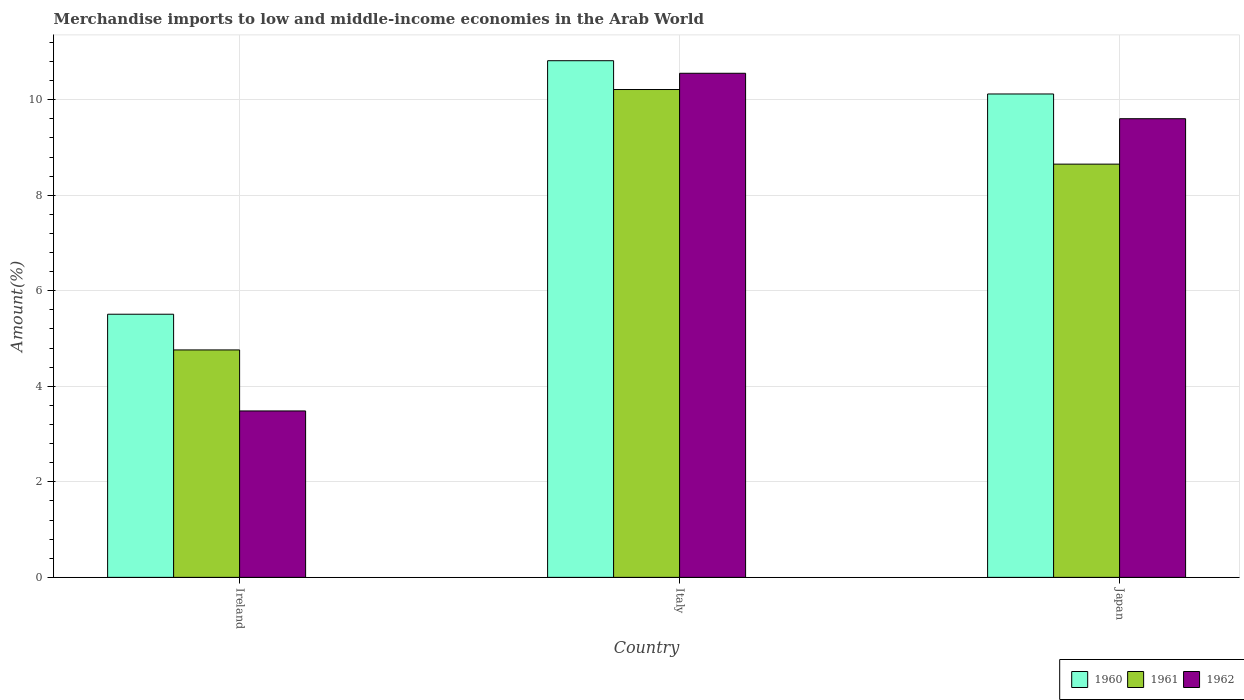How many different coloured bars are there?
Give a very brief answer. 3. How many groups of bars are there?
Your response must be concise. 3. How many bars are there on the 2nd tick from the right?
Offer a terse response. 3. What is the percentage of amount earned from merchandise imports in 1962 in Japan?
Provide a short and direct response. 9.6. Across all countries, what is the maximum percentage of amount earned from merchandise imports in 1962?
Offer a very short reply. 10.55. Across all countries, what is the minimum percentage of amount earned from merchandise imports in 1960?
Keep it short and to the point. 5.51. In which country was the percentage of amount earned from merchandise imports in 1961 maximum?
Provide a short and direct response. Italy. In which country was the percentage of amount earned from merchandise imports in 1960 minimum?
Your answer should be compact. Ireland. What is the total percentage of amount earned from merchandise imports in 1961 in the graph?
Provide a succinct answer. 23.63. What is the difference between the percentage of amount earned from merchandise imports in 1961 in Italy and that in Japan?
Offer a very short reply. 1.56. What is the difference between the percentage of amount earned from merchandise imports in 1961 in Ireland and the percentage of amount earned from merchandise imports in 1960 in Italy?
Give a very brief answer. -6.05. What is the average percentage of amount earned from merchandise imports in 1962 per country?
Offer a terse response. 7.88. What is the difference between the percentage of amount earned from merchandise imports of/in 1962 and percentage of amount earned from merchandise imports of/in 1960 in Japan?
Offer a terse response. -0.52. In how many countries, is the percentage of amount earned from merchandise imports in 1960 greater than 10.4 %?
Make the answer very short. 1. What is the ratio of the percentage of amount earned from merchandise imports in 1962 in Italy to that in Japan?
Provide a short and direct response. 1.1. Is the percentage of amount earned from merchandise imports in 1960 in Ireland less than that in Italy?
Provide a short and direct response. Yes. What is the difference between the highest and the second highest percentage of amount earned from merchandise imports in 1962?
Offer a terse response. -0.95. What is the difference between the highest and the lowest percentage of amount earned from merchandise imports in 1961?
Ensure brevity in your answer.  5.45. In how many countries, is the percentage of amount earned from merchandise imports in 1962 greater than the average percentage of amount earned from merchandise imports in 1962 taken over all countries?
Offer a very short reply. 2. Is the sum of the percentage of amount earned from merchandise imports in 1961 in Italy and Japan greater than the maximum percentage of amount earned from merchandise imports in 1962 across all countries?
Offer a terse response. Yes. What does the 1st bar from the left in Japan represents?
Your answer should be very brief. 1960. Is it the case that in every country, the sum of the percentage of amount earned from merchandise imports in 1961 and percentage of amount earned from merchandise imports in 1960 is greater than the percentage of amount earned from merchandise imports in 1962?
Your response must be concise. Yes. How many countries are there in the graph?
Give a very brief answer. 3. Does the graph contain any zero values?
Offer a terse response. No. Where does the legend appear in the graph?
Provide a succinct answer. Bottom right. How are the legend labels stacked?
Your answer should be compact. Horizontal. What is the title of the graph?
Your answer should be very brief. Merchandise imports to low and middle-income economies in the Arab World. What is the label or title of the Y-axis?
Your answer should be very brief. Amount(%). What is the Amount(%) in 1960 in Ireland?
Provide a short and direct response. 5.51. What is the Amount(%) of 1961 in Ireland?
Offer a very short reply. 4.76. What is the Amount(%) in 1962 in Ireland?
Keep it short and to the point. 3.48. What is the Amount(%) of 1960 in Italy?
Give a very brief answer. 10.82. What is the Amount(%) in 1961 in Italy?
Offer a terse response. 10.21. What is the Amount(%) of 1962 in Italy?
Your answer should be very brief. 10.55. What is the Amount(%) in 1960 in Japan?
Ensure brevity in your answer.  10.12. What is the Amount(%) in 1961 in Japan?
Your answer should be very brief. 8.65. What is the Amount(%) in 1962 in Japan?
Your answer should be very brief. 9.6. Across all countries, what is the maximum Amount(%) in 1960?
Give a very brief answer. 10.82. Across all countries, what is the maximum Amount(%) of 1961?
Your answer should be compact. 10.21. Across all countries, what is the maximum Amount(%) in 1962?
Provide a short and direct response. 10.55. Across all countries, what is the minimum Amount(%) in 1960?
Give a very brief answer. 5.51. Across all countries, what is the minimum Amount(%) of 1961?
Offer a terse response. 4.76. Across all countries, what is the minimum Amount(%) in 1962?
Provide a short and direct response. 3.48. What is the total Amount(%) in 1960 in the graph?
Give a very brief answer. 26.44. What is the total Amount(%) in 1961 in the graph?
Provide a succinct answer. 23.63. What is the total Amount(%) of 1962 in the graph?
Offer a very short reply. 23.64. What is the difference between the Amount(%) in 1960 in Ireland and that in Italy?
Your answer should be compact. -5.31. What is the difference between the Amount(%) in 1961 in Ireland and that in Italy?
Provide a succinct answer. -5.45. What is the difference between the Amount(%) in 1962 in Ireland and that in Italy?
Offer a very short reply. -7.07. What is the difference between the Amount(%) of 1960 in Ireland and that in Japan?
Ensure brevity in your answer.  -4.61. What is the difference between the Amount(%) of 1961 in Ireland and that in Japan?
Keep it short and to the point. -3.89. What is the difference between the Amount(%) in 1962 in Ireland and that in Japan?
Your answer should be compact. -6.12. What is the difference between the Amount(%) in 1960 in Italy and that in Japan?
Provide a succinct answer. 0.7. What is the difference between the Amount(%) of 1961 in Italy and that in Japan?
Give a very brief answer. 1.56. What is the difference between the Amount(%) of 1962 in Italy and that in Japan?
Your answer should be compact. 0.95. What is the difference between the Amount(%) of 1960 in Ireland and the Amount(%) of 1961 in Italy?
Keep it short and to the point. -4.7. What is the difference between the Amount(%) in 1960 in Ireland and the Amount(%) in 1962 in Italy?
Your answer should be compact. -5.04. What is the difference between the Amount(%) in 1961 in Ireland and the Amount(%) in 1962 in Italy?
Keep it short and to the point. -5.79. What is the difference between the Amount(%) in 1960 in Ireland and the Amount(%) in 1961 in Japan?
Ensure brevity in your answer.  -3.14. What is the difference between the Amount(%) in 1960 in Ireland and the Amount(%) in 1962 in Japan?
Keep it short and to the point. -4.09. What is the difference between the Amount(%) of 1961 in Ireland and the Amount(%) of 1962 in Japan?
Give a very brief answer. -4.84. What is the difference between the Amount(%) in 1960 in Italy and the Amount(%) in 1961 in Japan?
Provide a short and direct response. 2.17. What is the difference between the Amount(%) of 1960 in Italy and the Amount(%) of 1962 in Japan?
Offer a terse response. 1.21. What is the difference between the Amount(%) of 1961 in Italy and the Amount(%) of 1962 in Japan?
Your answer should be very brief. 0.61. What is the average Amount(%) of 1960 per country?
Your answer should be very brief. 8.81. What is the average Amount(%) in 1961 per country?
Offer a very short reply. 7.88. What is the average Amount(%) in 1962 per country?
Make the answer very short. 7.88. What is the difference between the Amount(%) in 1960 and Amount(%) in 1961 in Ireland?
Give a very brief answer. 0.75. What is the difference between the Amount(%) of 1960 and Amount(%) of 1962 in Ireland?
Make the answer very short. 2.02. What is the difference between the Amount(%) in 1961 and Amount(%) in 1962 in Ireland?
Your response must be concise. 1.28. What is the difference between the Amount(%) of 1960 and Amount(%) of 1961 in Italy?
Make the answer very short. 0.6. What is the difference between the Amount(%) in 1960 and Amount(%) in 1962 in Italy?
Make the answer very short. 0.26. What is the difference between the Amount(%) in 1961 and Amount(%) in 1962 in Italy?
Make the answer very short. -0.34. What is the difference between the Amount(%) of 1960 and Amount(%) of 1961 in Japan?
Your answer should be compact. 1.47. What is the difference between the Amount(%) in 1960 and Amount(%) in 1962 in Japan?
Provide a short and direct response. 0.52. What is the difference between the Amount(%) of 1961 and Amount(%) of 1962 in Japan?
Keep it short and to the point. -0.95. What is the ratio of the Amount(%) of 1960 in Ireland to that in Italy?
Your answer should be very brief. 0.51. What is the ratio of the Amount(%) in 1961 in Ireland to that in Italy?
Your answer should be very brief. 0.47. What is the ratio of the Amount(%) in 1962 in Ireland to that in Italy?
Your answer should be compact. 0.33. What is the ratio of the Amount(%) in 1960 in Ireland to that in Japan?
Keep it short and to the point. 0.54. What is the ratio of the Amount(%) of 1961 in Ireland to that in Japan?
Ensure brevity in your answer.  0.55. What is the ratio of the Amount(%) in 1962 in Ireland to that in Japan?
Provide a succinct answer. 0.36. What is the ratio of the Amount(%) of 1960 in Italy to that in Japan?
Provide a succinct answer. 1.07. What is the ratio of the Amount(%) in 1961 in Italy to that in Japan?
Offer a terse response. 1.18. What is the ratio of the Amount(%) in 1962 in Italy to that in Japan?
Keep it short and to the point. 1.1. What is the difference between the highest and the second highest Amount(%) of 1960?
Provide a succinct answer. 0.7. What is the difference between the highest and the second highest Amount(%) in 1961?
Keep it short and to the point. 1.56. What is the difference between the highest and the second highest Amount(%) of 1962?
Offer a terse response. 0.95. What is the difference between the highest and the lowest Amount(%) in 1960?
Offer a terse response. 5.31. What is the difference between the highest and the lowest Amount(%) in 1961?
Keep it short and to the point. 5.45. What is the difference between the highest and the lowest Amount(%) in 1962?
Provide a short and direct response. 7.07. 